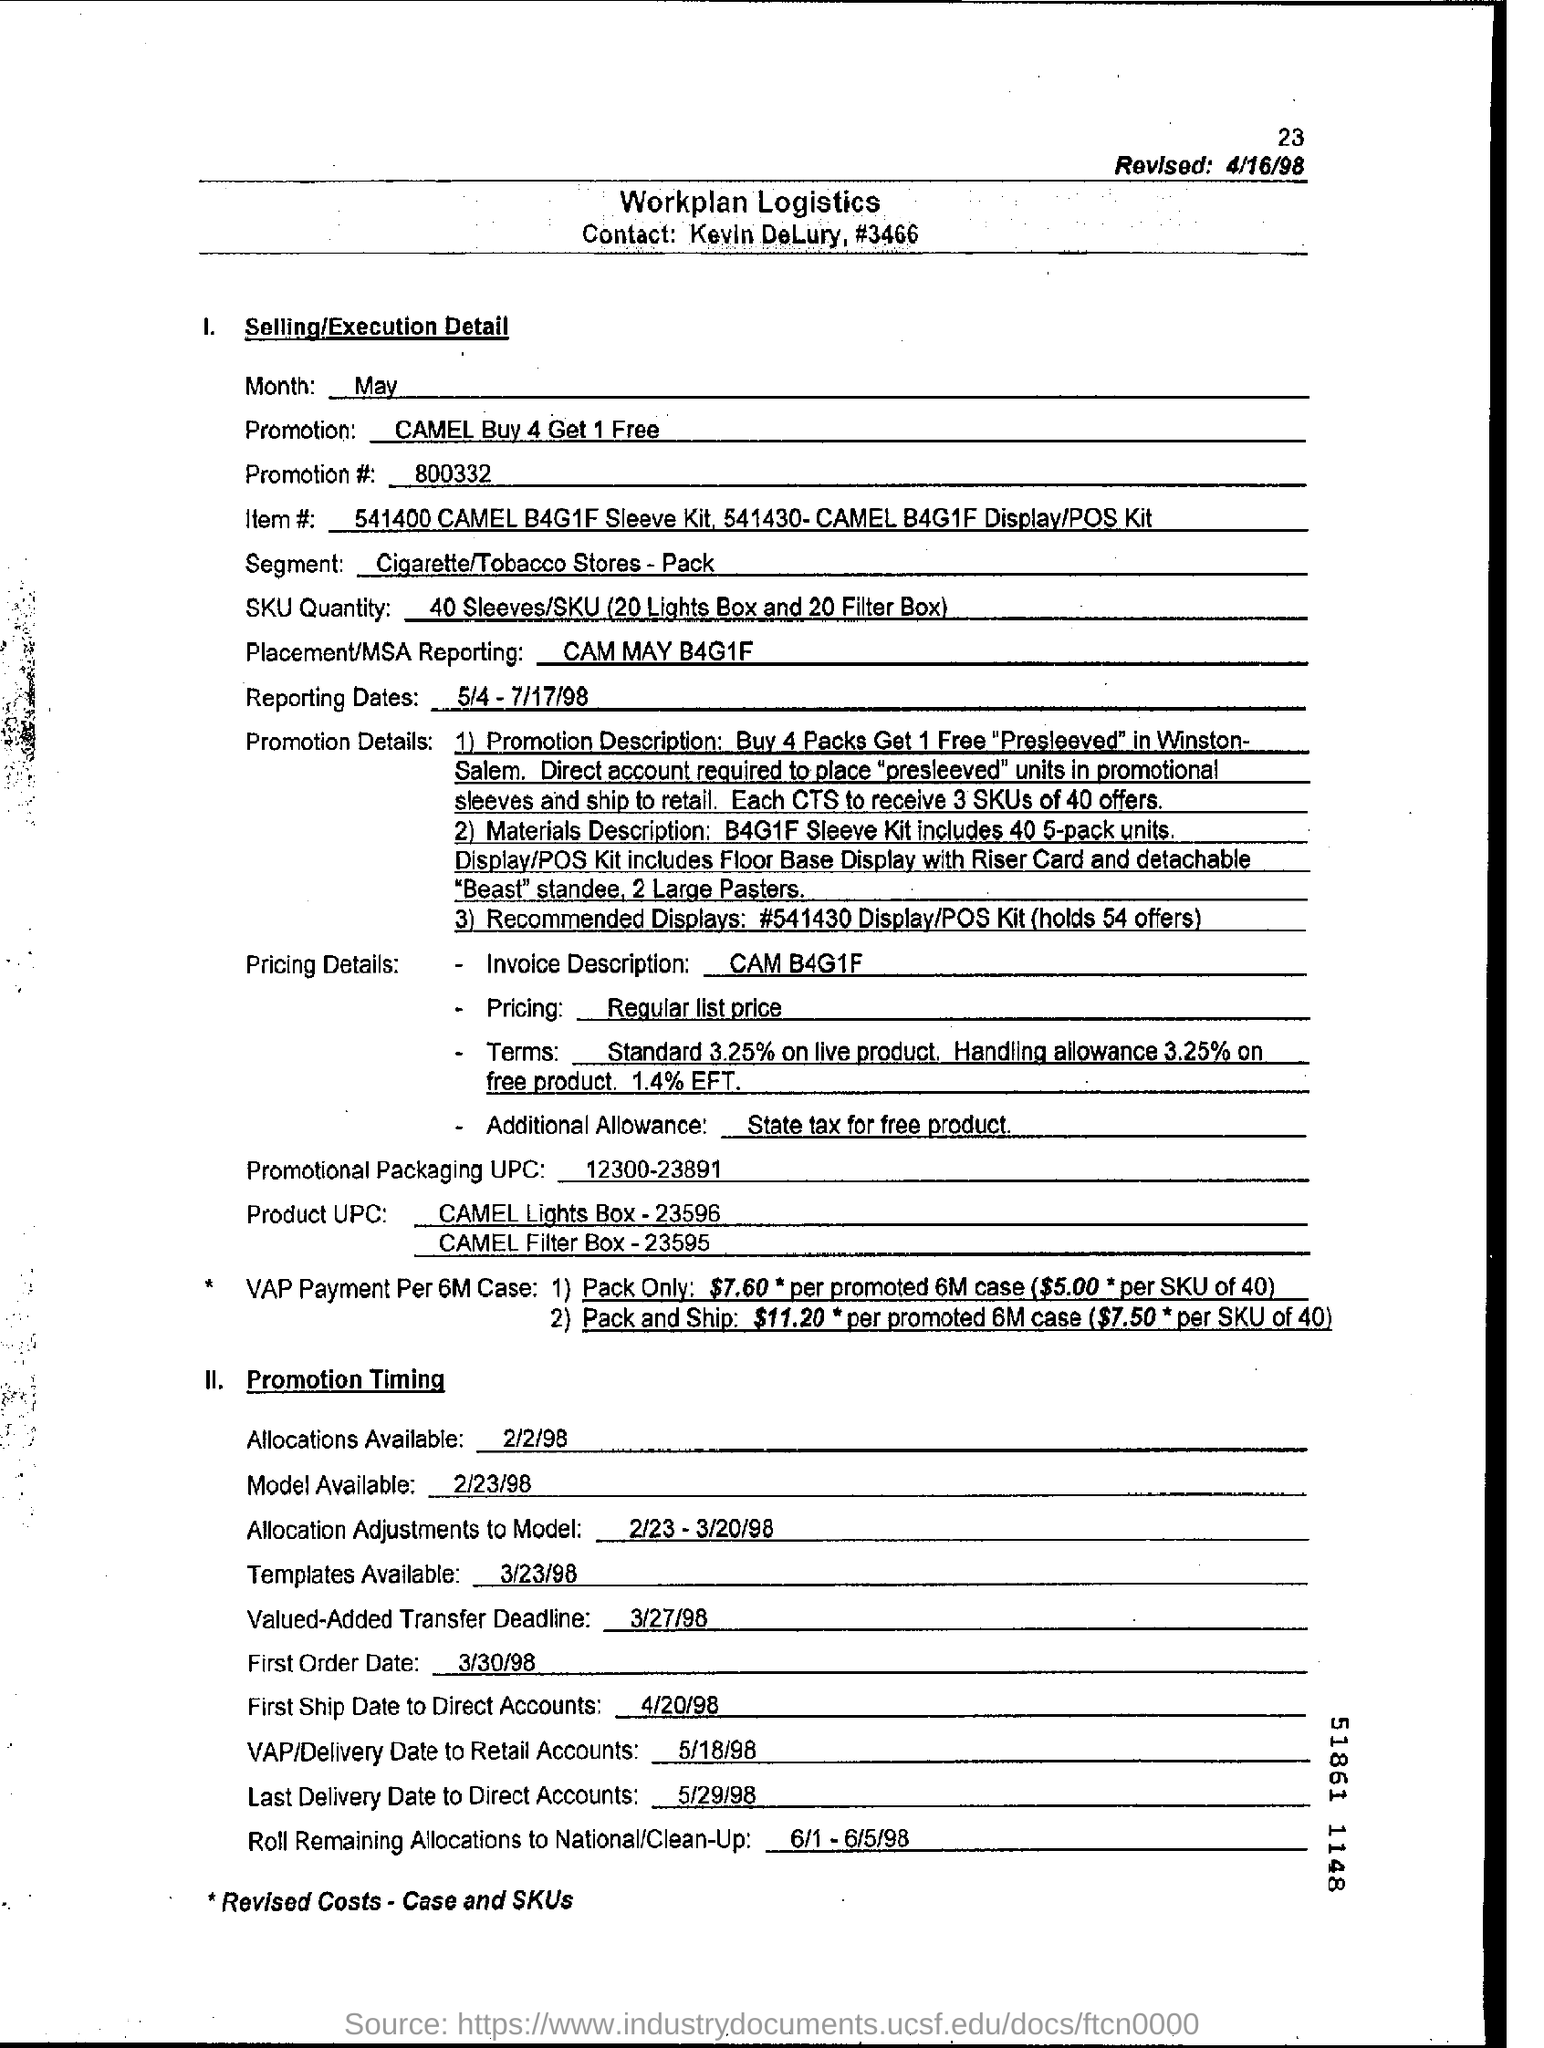What is the Promotion #?
 800332 